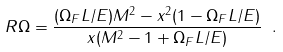Convert formula to latex. <formula><loc_0><loc_0><loc_500><loc_500>R \Omega = \frac { ( \Omega _ { F } L / E ) M ^ { 2 } - x ^ { 2 } ( 1 - \Omega _ { F } L / E ) } { x ( M ^ { 2 } - 1 + \Omega _ { F } L / E ) } \ .</formula> 